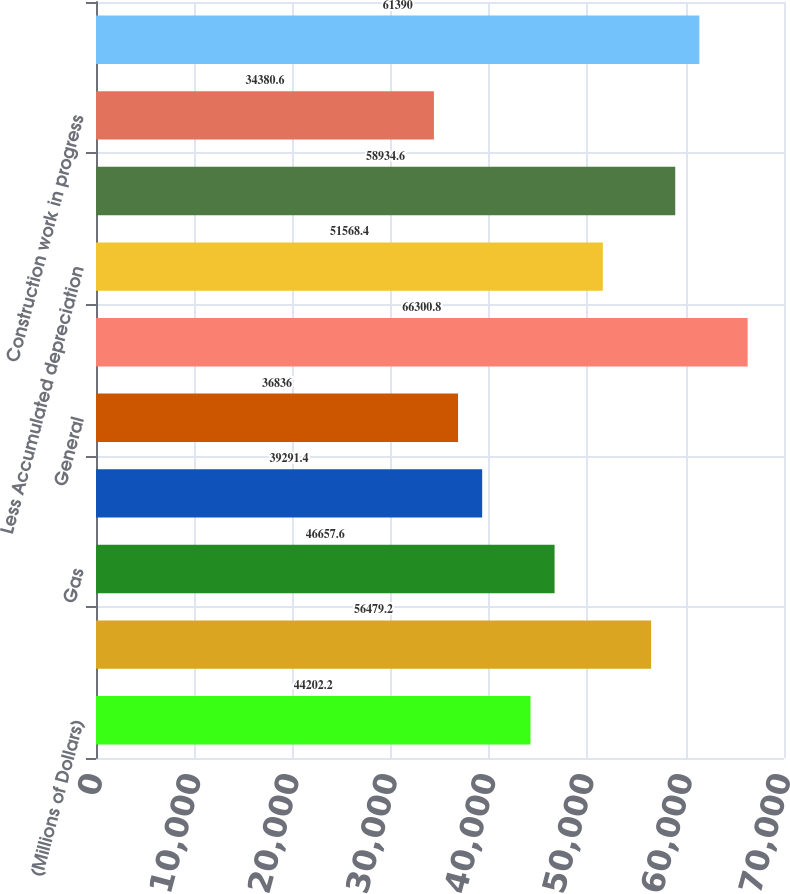<chart> <loc_0><loc_0><loc_500><loc_500><bar_chart><fcel>(Millions of Dollars)<fcel>Electric<fcel>Gas<fcel>Steam<fcel>General<fcel>Total<fcel>Less Accumulated depreciation<fcel>Net<fcel>Construction work in progress<fcel>Net Utility Plant<nl><fcel>44202.2<fcel>56479.2<fcel>46657.6<fcel>39291.4<fcel>36836<fcel>66300.8<fcel>51568.4<fcel>58934.6<fcel>34380.6<fcel>61390<nl></chart> 